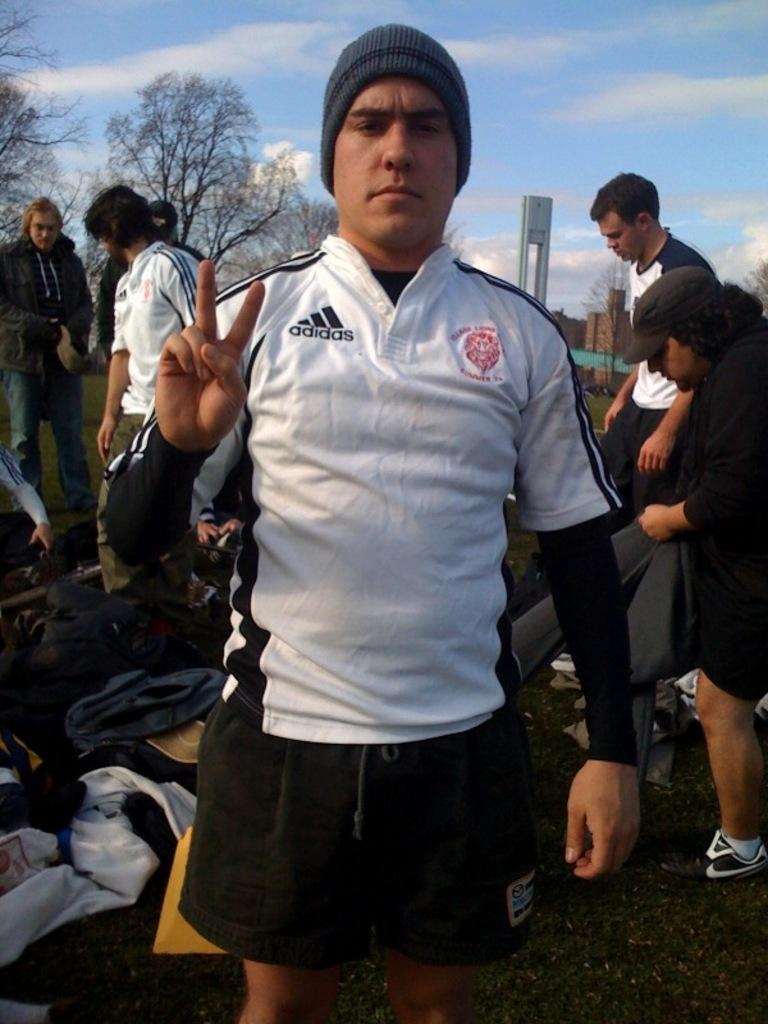<image>
Share a concise interpretation of the image provided. A man dressed in a white Adidas written on his shirt  with two fingers up. 